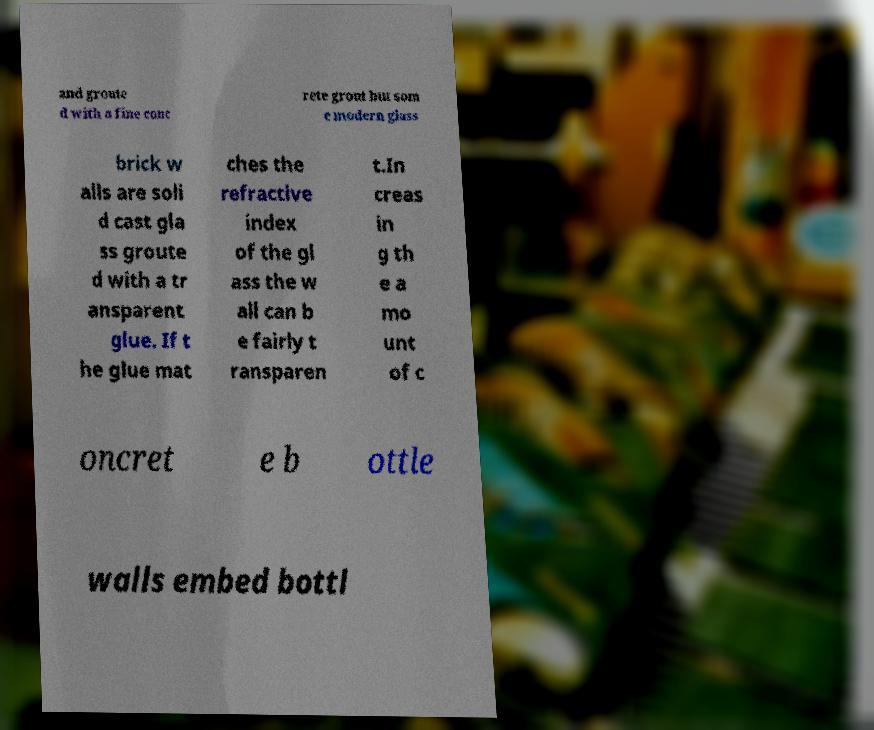Please identify and transcribe the text found in this image. and groute d with a fine conc rete grout but som e modern glass brick w alls are soli d cast gla ss groute d with a tr ansparent glue. If t he glue mat ches the refractive index of the gl ass the w all can b e fairly t ransparen t.In creas in g th e a mo unt of c oncret e b ottle walls embed bottl 